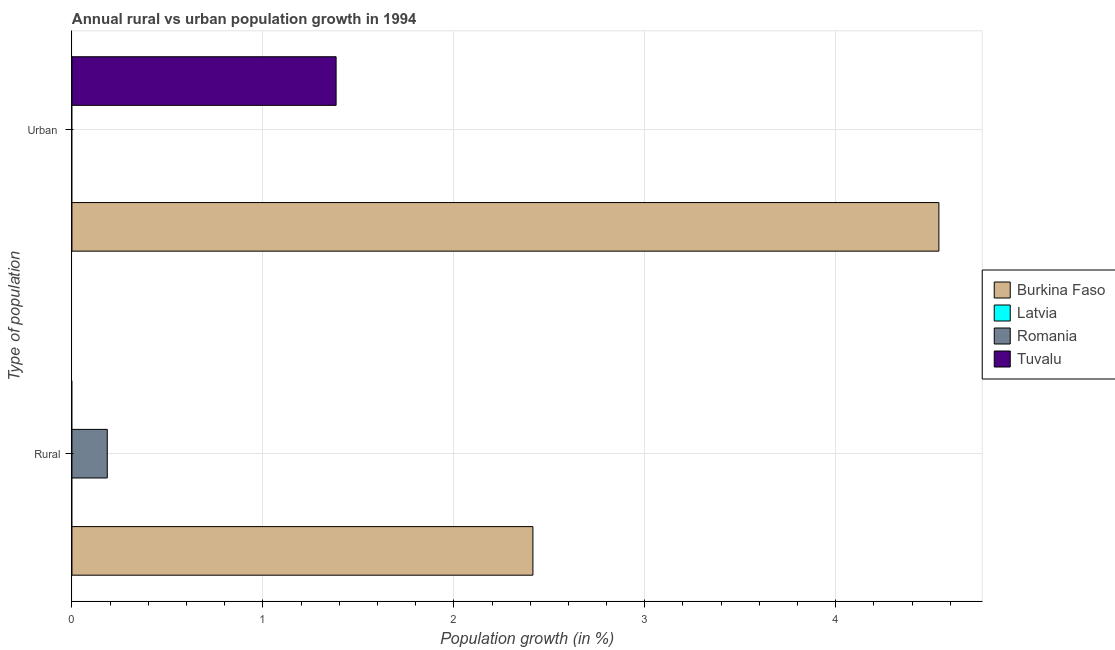How many bars are there on the 1st tick from the bottom?
Offer a terse response. 2. What is the label of the 2nd group of bars from the top?
Your response must be concise. Rural. What is the rural population growth in Romania?
Provide a succinct answer. 0.19. Across all countries, what is the maximum urban population growth?
Make the answer very short. 4.54. Across all countries, what is the minimum urban population growth?
Make the answer very short. 0. In which country was the urban population growth maximum?
Give a very brief answer. Burkina Faso. What is the total rural population growth in the graph?
Your answer should be compact. 2.6. What is the difference between the rural population growth in Tuvalu and the urban population growth in Burkina Faso?
Offer a terse response. -4.54. What is the average urban population growth per country?
Provide a short and direct response. 1.48. What is the difference between the rural population growth and urban population growth in Burkina Faso?
Provide a short and direct response. -2.13. In how many countries, is the urban population growth greater than the average urban population growth taken over all countries?
Offer a terse response. 1. Are all the bars in the graph horizontal?
Your answer should be very brief. Yes. Are the values on the major ticks of X-axis written in scientific E-notation?
Your answer should be compact. No. Does the graph contain any zero values?
Your answer should be very brief. Yes. Where does the legend appear in the graph?
Your answer should be very brief. Center right. How many legend labels are there?
Ensure brevity in your answer.  4. How are the legend labels stacked?
Offer a terse response. Vertical. What is the title of the graph?
Offer a very short reply. Annual rural vs urban population growth in 1994. What is the label or title of the X-axis?
Your response must be concise. Population growth (in %). What is the label or title of the Y-axis?
Make the answer very short. Type of population. What is the Population growth (in %) of Burkina Faso in Rural?
Your answer should be very brief. 2.41. What is the Population growth (in %) of Romania in Rural?
Provide a succinct answer. 0.19. What is the Population growth (in %) of Tuvalu in Rural?
Your answer should be very brief. 0. What is the Population growth (in %) in Burkina Faso in Urban ?
Offer a terse response. 4.54. What is the Population growth (in %) in Tuvalu in Urban ?
Your response must be concise. 1.38. Across all Type of population, what is the maximum Population growth (in %) of Burkina Faso?
Offer a terse response. 4.54. Across all Type of population, what is the maximum Population growth (in %) in Romania?
Offer a very short reply. 0.19. Across all Type of population, what is the maximum Population growth (in %) in Tuvalu?
Make the answer very short. 1.38. Across all Type of population, what is the minimum Population growth (in %) in Burkina Faso?
Provide a short and direct response. 2.41. Across all Type of population, what is the minimum Population growth (in %) in Tuvalu?
Your response must be concise. 0. What is the total Population growth (in %) of Burkina Faso in the graph?
Keep it short and to the point. 6.95. What is the total Population growth (in %) in Romania in the graph?
Make the answer very short. 0.18. What is the total Population growth (in %) of Tuvalu in the graph?
Your response must be concise. 1.38. What is the difference between the Population growth (in %) of Burkina Faso in Rural and that in Urban ?
Provide a short and direct response. -2.13. What is the difference between the Population growth (in %) in Burkina Faso in Rural and the Population growth (in %) in Tuvalu in Urban ?
Make the answer very short. 1.03. What is the difference between the Population growth (in %) of Romania in Rural and the Population growth (in %) of Tuvalu in Urban ?
Provide a succinct answer. -1.2. What is the average Population growth (in %) of Burkina Faso per Type of population?
Make the answer very short. 3.48. What is the average Population growth (in %) in Latvia per Type of population?
Ensure brevity in your answer.  0. What is the average Population growth (in %) of Romania per Type of population?
Provide a succinct answer. 0.09. What is the average Population growth (in %) of Tuvalu per Type of population?
Give a very brief answer. 0.69. What is the difference between the Population growth (in %) in Burkina Faso and Population growth (in %) in Romania in Rural?
Your answer should be compact. 2.23. What is the difference between the Population growth (in %) in Burkina Faso and Population growth (in %) in Tuvalu in Urban ?
Provide a short and direct response. 3.16. What is the ratio of the Population growth (in %) of Burkina Faso in Rural to that in Urban ?
Your answer should be very brief. 0.53. What is the difference between the highest and the second highest Population growth (in %) in Burkina Faso?
Your answer should be very brief. 2.13. What is the difference between the highest and the lowest Population growth (in %) in Burkina Faso?
Your response must be concise. 2.13. What is the difference between the highest and the lowest Population growth (in %) of Romania?
Offer a very short reply. 0.18. What is the difference between the highest and the lowest Population growth (in %) in Tuvalu?
Your answer should be compact. 1.38. 